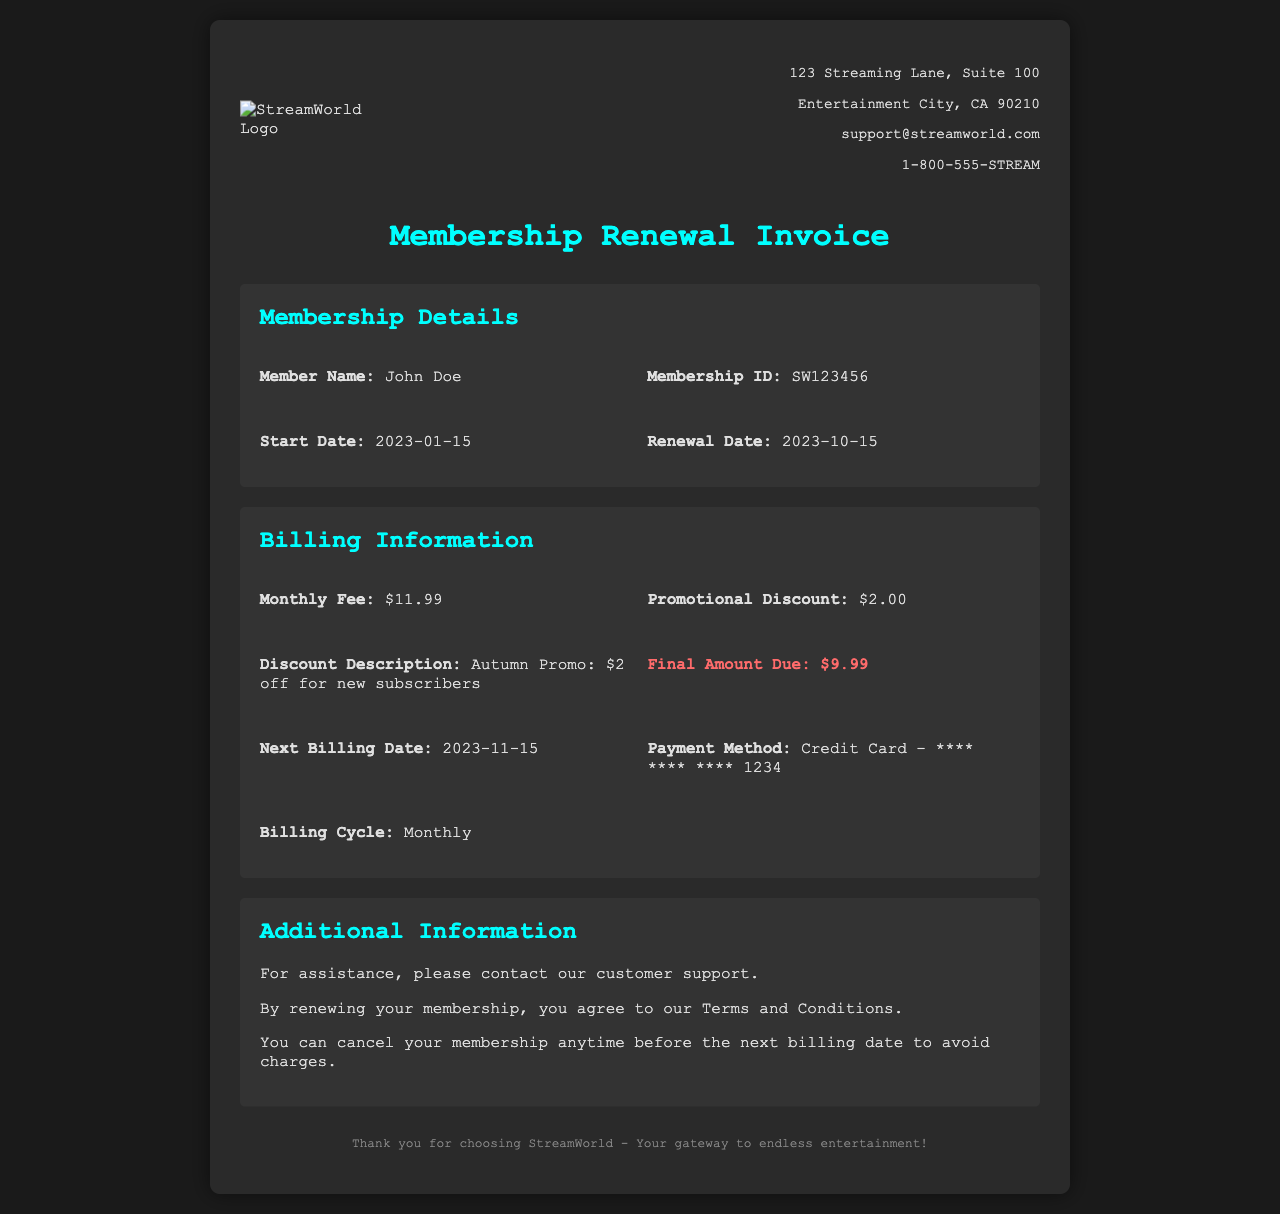What is the member name? The member name is specified in the membership details section of the document.
Answer: John Doe What is the monthly fee? The monthly fee is explicitly stated in the billing information section.
Answer: $11.99 What is the promotional discount amount? The promotional discount amount is mentioned in the billing information section.
Answer: $2.00 What is the final amount due? The final amount due is highlighted in the billing information section.
Answer: $9.99 When is the next billing date? The next billing date is provided in the billing information section of the document.
Answer: 2023-11-15 What is the payment method? The payment method is clearly stated in the billing information section of the invoice.
Answer: Credit Card - **** **** **** 1234 What is the membership ID? The membership ID is included in the membership details section of the document.
Answer: SW123456 What is the discount description? The discount description explains the promotional discount and is found in the billing information section.
Answer: Autumn Promo: $2 off for new subscribers What can a member do before the next billing date? The document mentions actions that can be taken by the member regarding their membership.
Answer: Cancel membership What type of document is this? The content and layout of the document indicate its primary purpose.
Answer: Invoice 